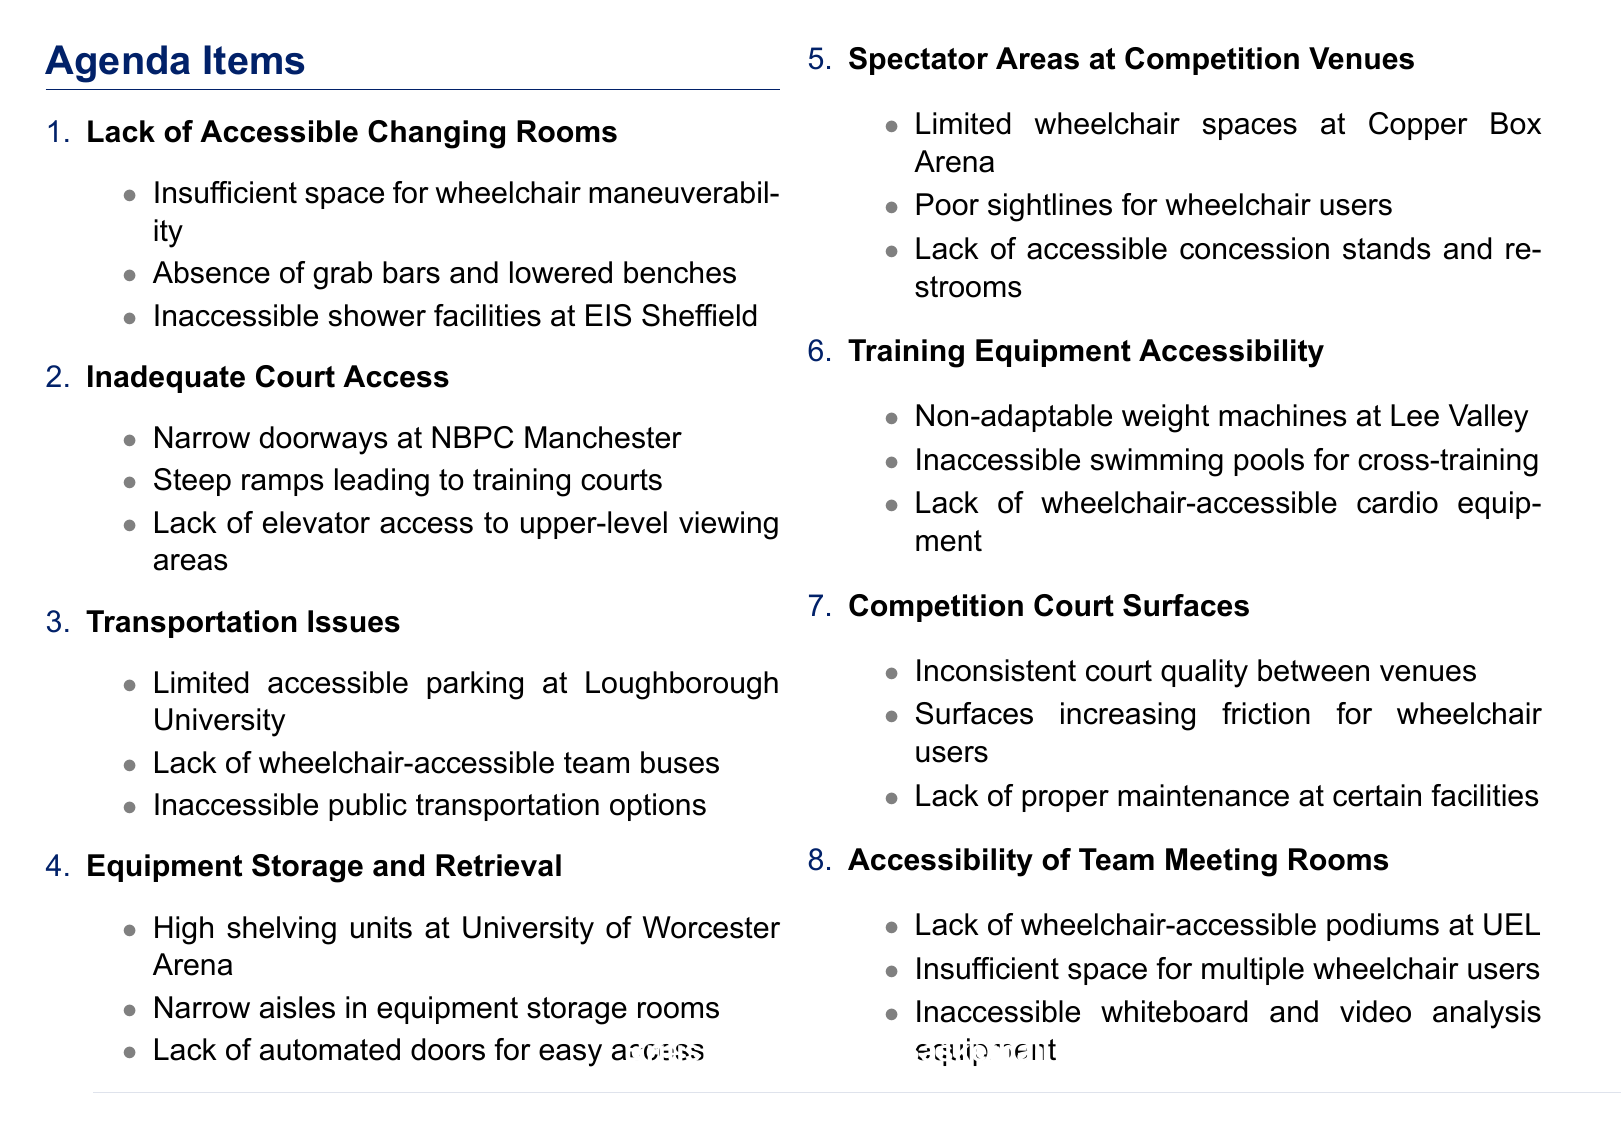What is one issue related to changing rooms? The document lists several specific issues, including "Insufficient space for wheelchair maneuverability."
Answer: Insufficient space for wheelchair maneuverability Which facility has inaccessible shower facilities? The agenda mentions "Inaccessible shower facilities at the English Institute of Sport in Sheffield" as a specific detail.
Answer: English Institute of Sport in Sheffield What transportation issue is highlighted at Loughborough University? The document states one of the issues as "Limited accessible parking spaces at Loughborough University's Wheelchair Basketball Centre."
Answer: Limited accessible parking spaces How many agenda items are listed in the document? The document enumerates 8 distinct agenda items related to accessibility issues.
Answer: 8 What is a problem identified with spectator areas at competition venues? The agenda specifies issues such as "Limited wheelchair spaces at the Copper Box Arena in London," highlighting spectator accessibility issues.
Answer: Limited wheelchair spaces What is noted about court surfaces in the document? One of the issues mentioned includes "Inconsistent court quality between training and competition venues."
Answer: Inconsistent court quality Which training facility has non-adaptable weight machines? The document specifically mentions "Non-adaptable weight machines at the Lee Valley Athletics Centre" as a concern.
Answer: Lee Valley Athletics Centre What facility lacks wheelchair-accessible podiums for coaches? The document highlights "Lack of wheelchair-accessible podiums for coaches at the University of East London SportsDock."
Answer: University of East London SportsDock 